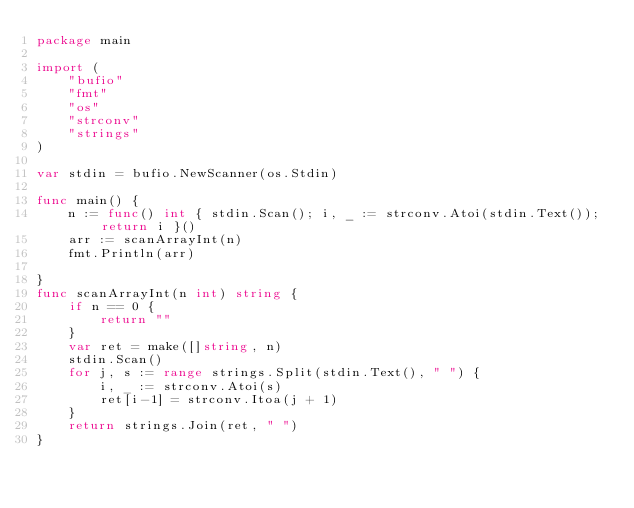Convert code to text. <code><loc_0><loc_0><loc_500><loc_500><_Go_>package main

import (
	"bufio"
	"fmt"
	"os"
	"strconv"
	"strings"
)

var stdin = bufio.NewScanner(os.Stdin)

func main() {
	n := func() int { stdin.Scan(); i, _ := strconv.Atoi(stdin.Text()); return i }()
	arr := scanArrayInt(n)
	fmt.Println(arr)

}
func scanArrayInt(n int) string {
	if n == 0 {
		return ""
	}
	var ret = make([]string, n)
	stdin.Scan()
	for j, s := range strings.Split(stdin.Text(), " ") {
		i, _ := strconv.Atoi(s)
		ret[i-1] = strconv.Itoa(j + 1)
	}
	return strings.Join(ret, " ")
}</code> 